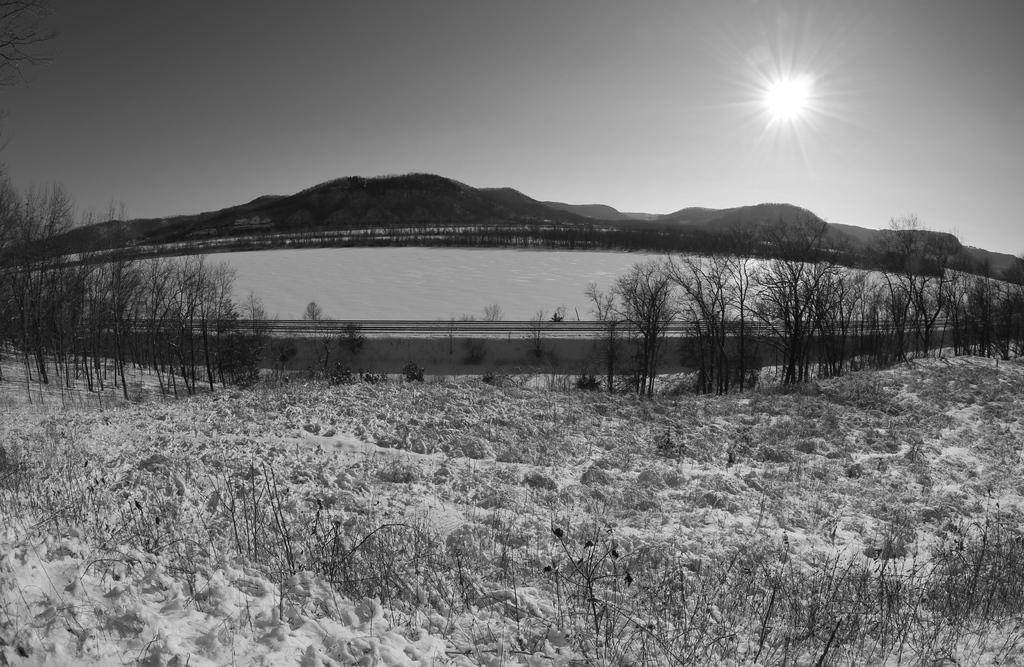What is the color scheme of the photograph? The photograph is black and white. What is the main subject of the image? The photograph depicts a river. What can be seen in the background of the image? There are dry trees and mountains visible in the background. What is the condition of the sky in the image? The sky is clear and visible in the image. How many cacti are present in the image? There are no cacti visible in the image. What type of bottle can be seen floating in the river? There is no bottle present in the image. 